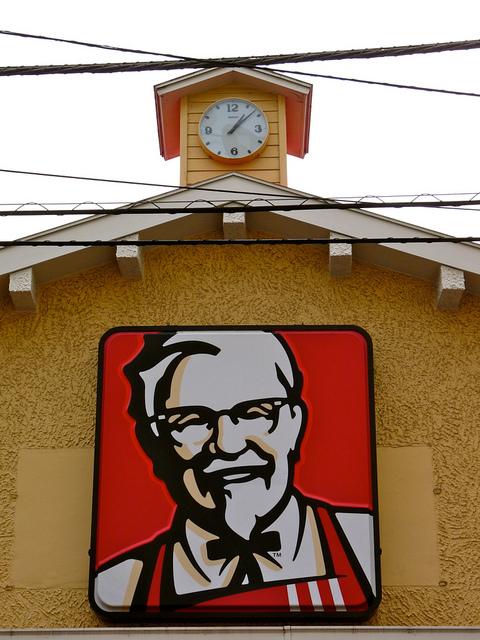What time is on the clock?
Give a very brief answer. 1:08. Who is on the picture?
Be succinct. Colonel sanders. What is the name of this place?
Answer briefly. Kfc. 